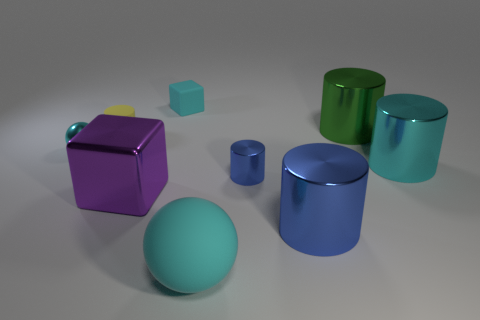Subtract all purple spheres. How many blue cylinders are left? 2 Subtract 3 cylinders. How many cylinders are left? 2 Subtract all metal cylinders. How many cylinders are left? 1 Subtract all green cylinders. How many cylinders are left? 4 Subtract all yellow cylinders. Subtract all blue spheres. How many cylinders are left? 4 Subtract all things. Subtract all tiny yellow rubber cubes. How many objects are left? 0 Add 6 yellow rubber things. How many yellow rubber things are left? 7 Add 6 small green rubber cylinders. How many small green rubber cylinders exist? 6 Subtract 0 red blocks. How many objects are left? 9 Subtract all spheres. How many objects are left? 7 